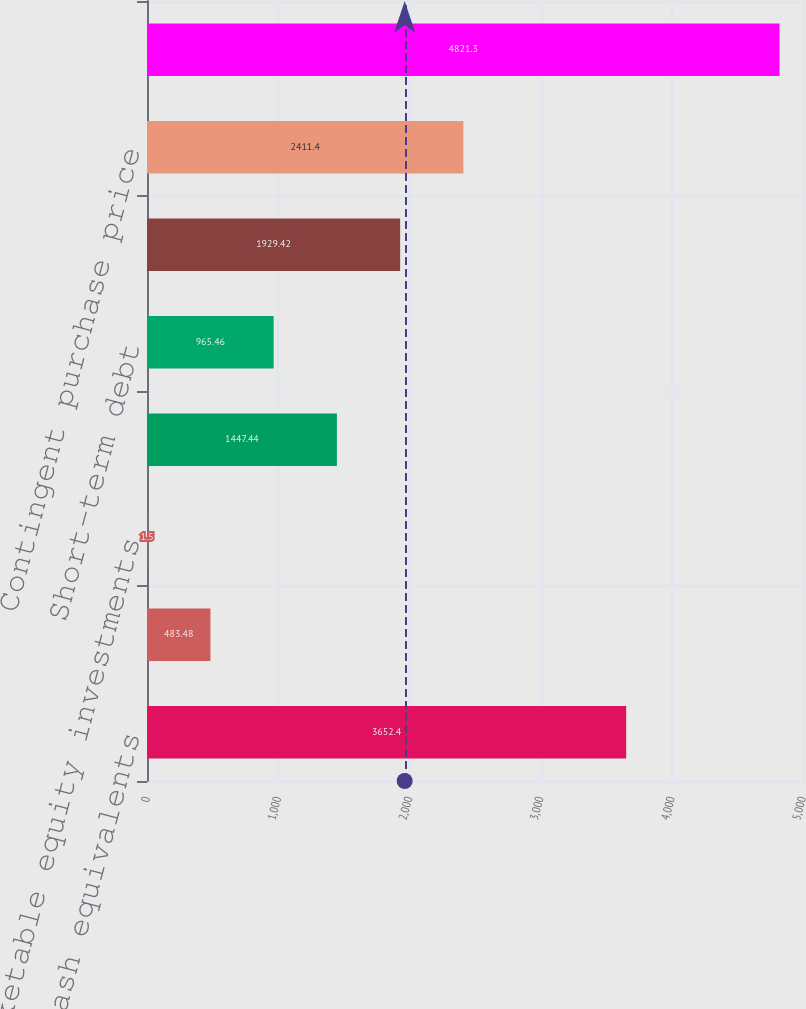Convert chart to OTSL. <chart><loc_0><loc_0><loc_500><loc_500><bar_chart><fcel>Cash and cash equivalents<fcel>Short-term investments<fcel>Marketable equity investments<fcel>Non-marketable equity<fcel>Short-term debt<fcel>Interest rate and foreign<fcel>Contingent purchase price<fcel>Long-term debt including<nl><fcel>3652.4<fcel>483.48<fcel>1.5<fcel>1447.44<fcel>965.46<fcel>1929.42<fcel>2411.4<fcel>4821.3<nl></chart> 